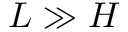<formula> <loc_0><loc_0><loc_500><loc_500>L \gg H</formula> 